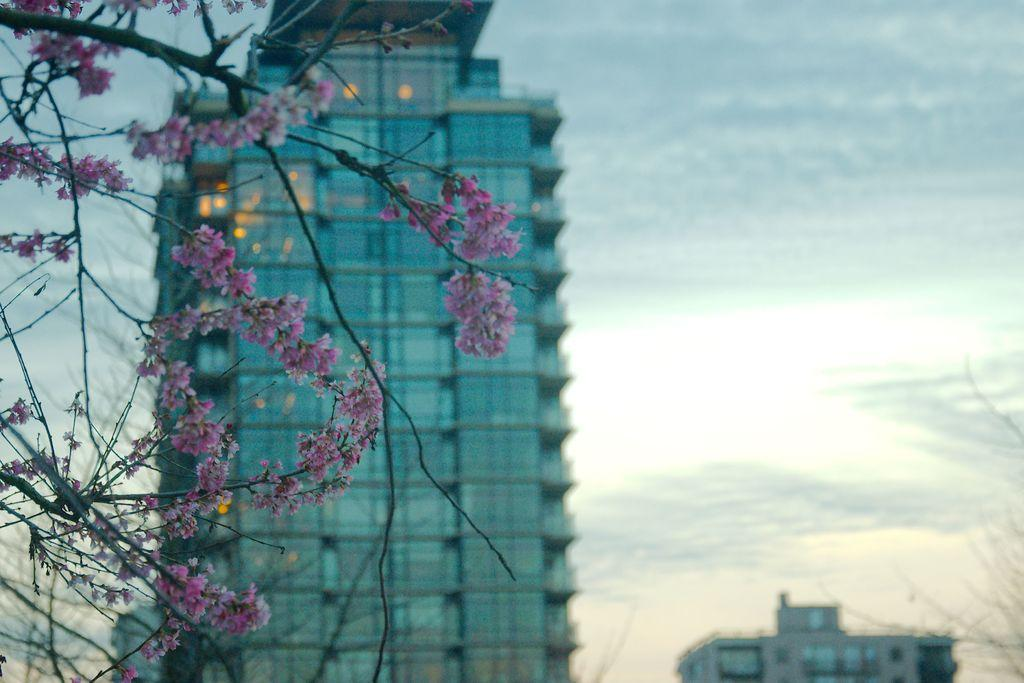What type of plant is on the left side of the image? There is a plant with flowers on the left side of the image. What can be seen in the distance behind the plant? There are buildings in the background of the image. What type of doors are visible in the background? There are glass doors in the background of the image. What is visible in the sky in the background? There are clouds in the sky in the background of the image. How far away is the ocean from the plant in the image? There is no ocean visible in the image; it only shows a plant with flowers, buildings, glass doors, and clouds in the sky. 